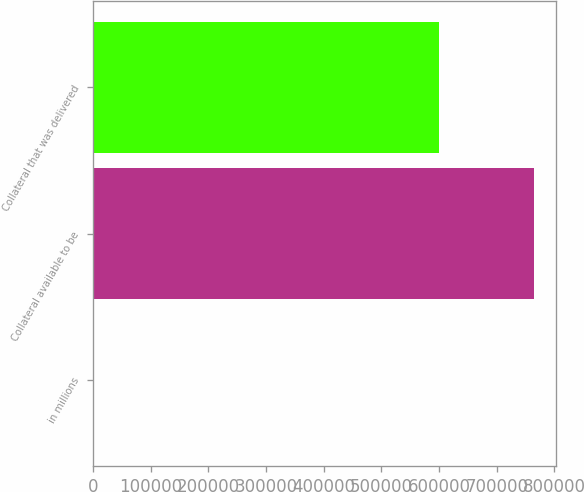Convert chart to OTSL. <chart><loc_0><loc_0><loc_500><loc_500><bar_chart><fcel>in millions<fcel>Collateral available to be<fcel>Collateral that was delivered<nl><fcel>2017<fcel>763984<fcel>599565<nl></chart> 